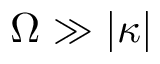<formula> <loc_0><loc_0><loc_500><loc_500>\Omega \gg | \kappa |</formula> 